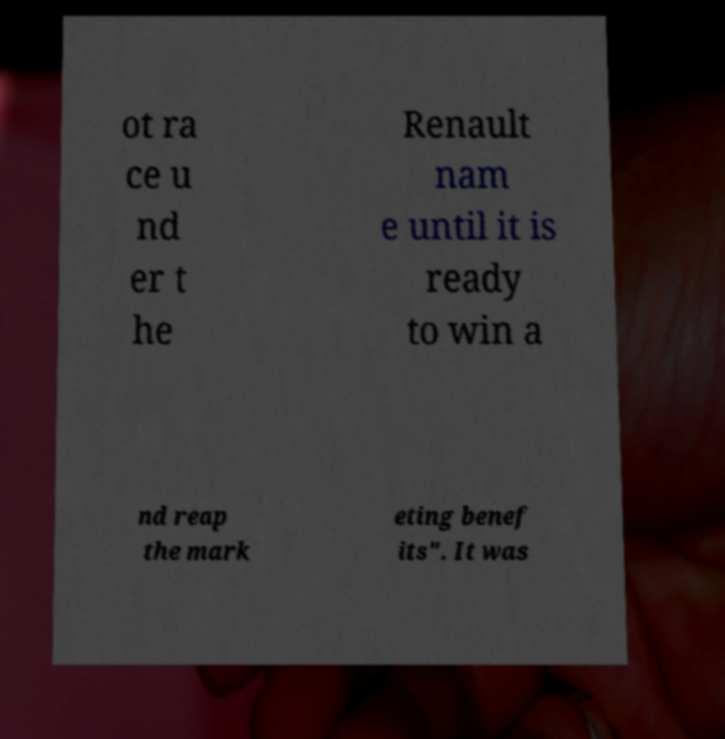Can you read and provide the text displayed in the image?This photo seems to have some interesting text. Can you extract and type it out for me? ot ra ce u nd er t he Renault nam e until it is ready to win a nd reap the mark eting benef its". It was 